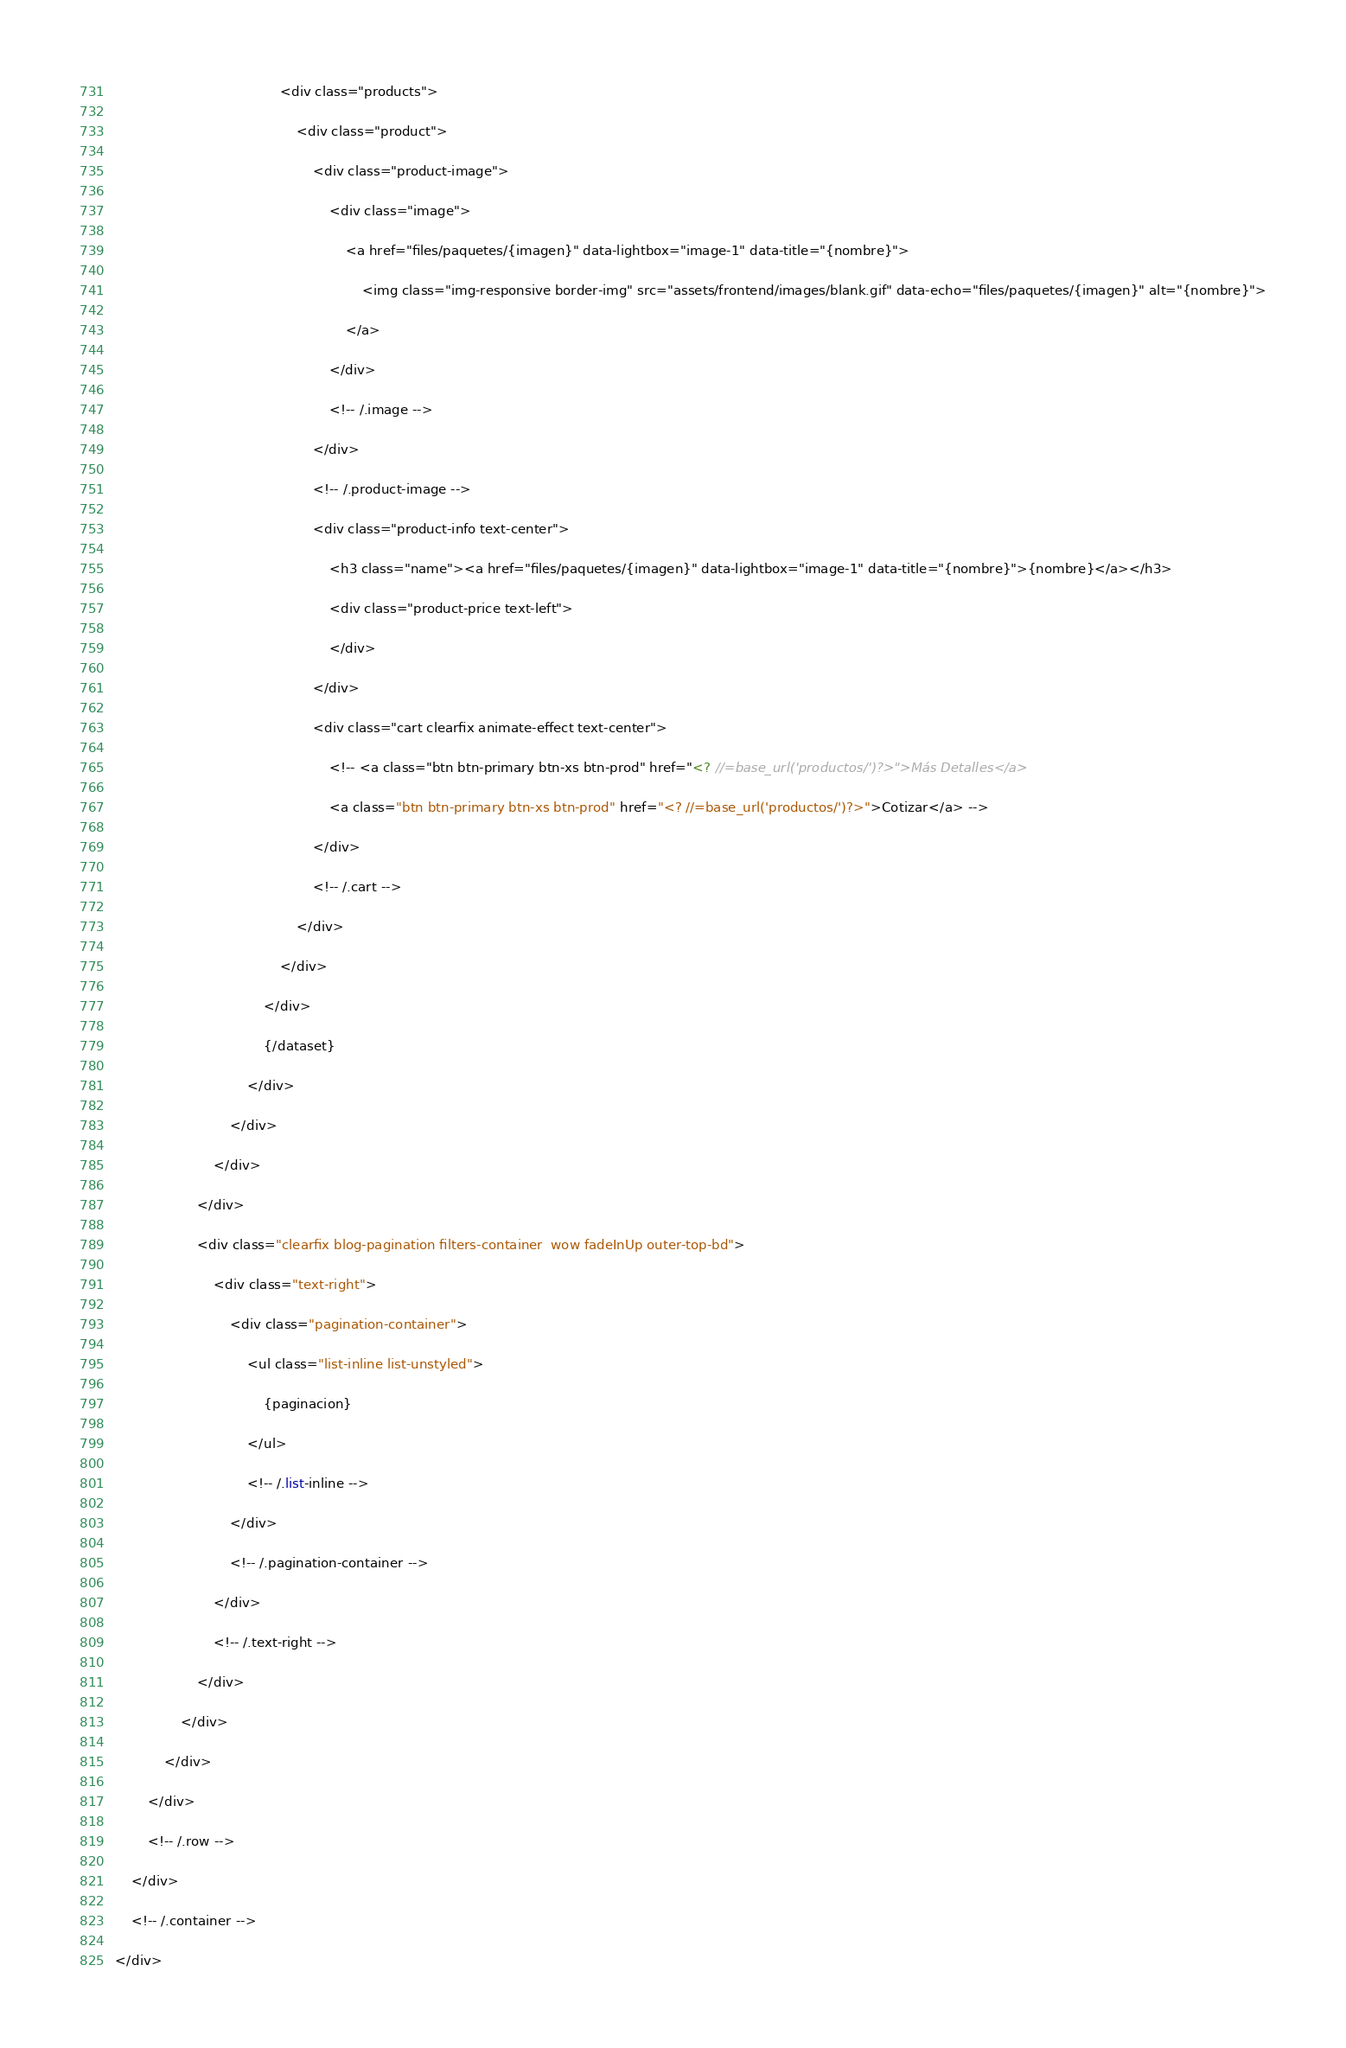Convert code to text. <code><loc_0><loc_0><loc_500><loc_500><_PHP_>										<div class="products">
											<div class="product">
												<div class="product-image">
													<div class="image">
														<a href="files/paquetes/{imagen}" data-lightbox="image-1" data-title="{nombre}">
															<img class="img-responsive border-img" src="assets/frontend/images/blank.gif" data-echo="files/paquetes/{imagen}" alt="{nombre}">
														</a>
													</div>
													<!-- /.image -->
												</div>
												<!-- /.product-image -->
												<div class="product-info text-center">
													<h3 class="name"><a href="files/paquetes/{imagen}" data-lightbox="image-1" data-title="{nombre}">{nombre}</a></h3>
													<div class="product-price text-left">
													</div>
												</div>
												<div class="cart clearfix animate-effect text-center">
													<!-- <a class="btn btn-primary btn-xs btn-prod" href="<? //=base_url('productos/')?>">Más Detalles</a>
													<a class="btn btn-primary btn-xs btn-prod" href="<? //=base_url('productos/')?>">Cotizar</a> -->
												</div>
												<!-- /.cart -->
											</div>
										</div>
									</div>
									{/dataset}
								</div>
							</div>
						</div>
					</div>
					<div class="clearfix blog-pagination filters-container  wow fadeInUp outer-top-bd">
						<div class="text-right">
							<div class="pagination-container">
								<ul class="list-inline list-unstyled">
									{paginacion}
								</ul>
								<!-- /.list-inline -->
							</div>
							<!-- /.pagination-container -->  
						</div>
						<!-- /.text-right -->
					</div>
				</div>
			</div>
        </div>
        <!-- /.row -->
    </div>
    <!-- /.container -->
</div></code> 